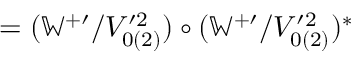<formula> <loc_0><loc_0><loc_500><loc_500>= ( \mathbb { W } ^ { + \prime } / V _ { 0 ( 2 ) } ^ { \prime 2 } ) \circ ( \mathbb { W } ^ { + \prime } / V _ { 0 ( 2 ) } ^ { \prime 2 } ) ^ { \ast }</formula> 